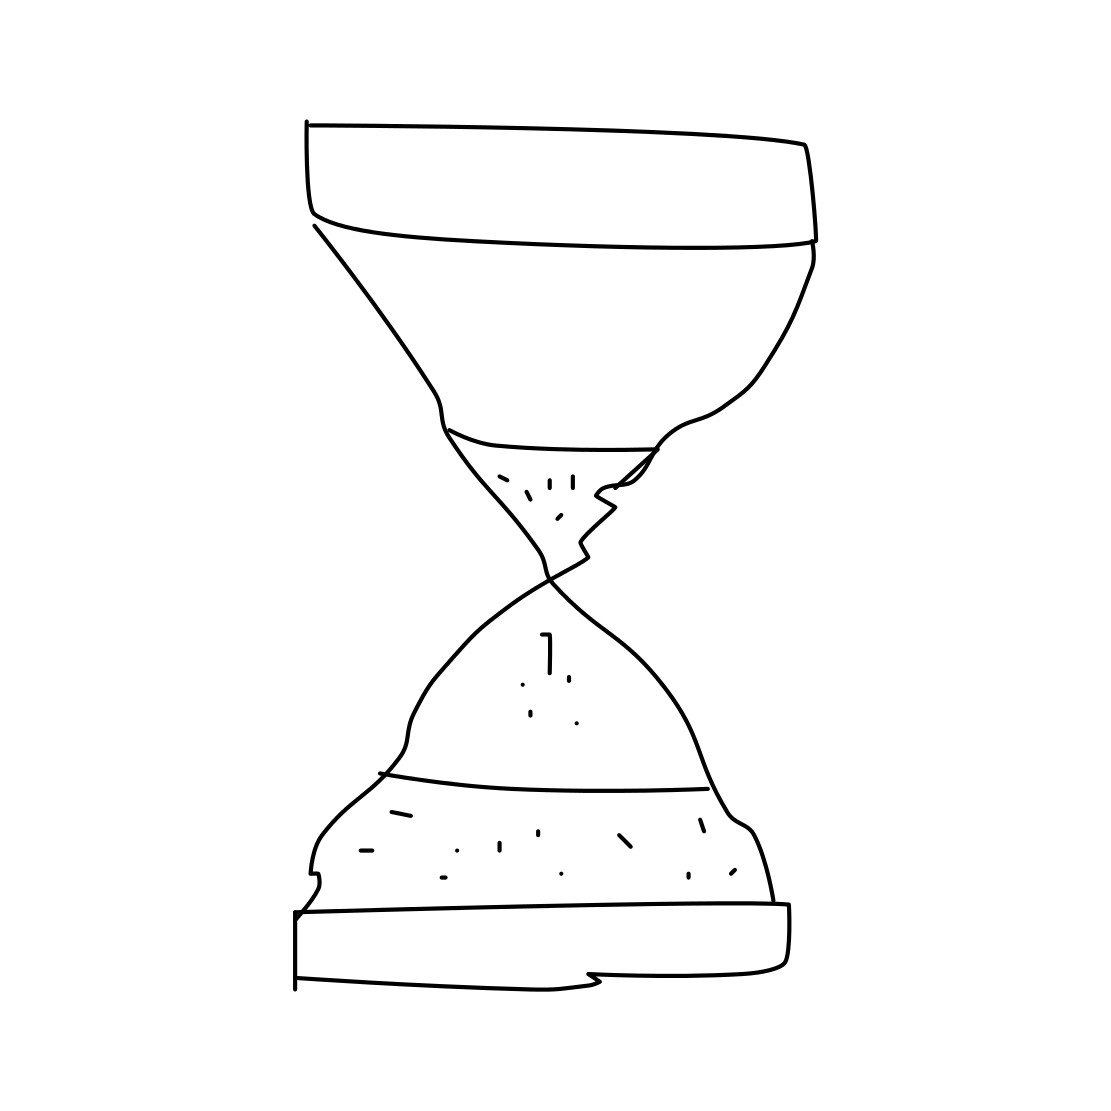What would be different if the hourglass was depicted with sand running through it? If the hourglass in the image had sand flowing through it, it would give the impression of active measurement of time and could be interpreted as a metaphor for an ongoing process or countdown. It might suggest the need to pay attention to the time we have left, either in a literal sense (like cooking or playing games), or metaphorically in life events and opportunities. 